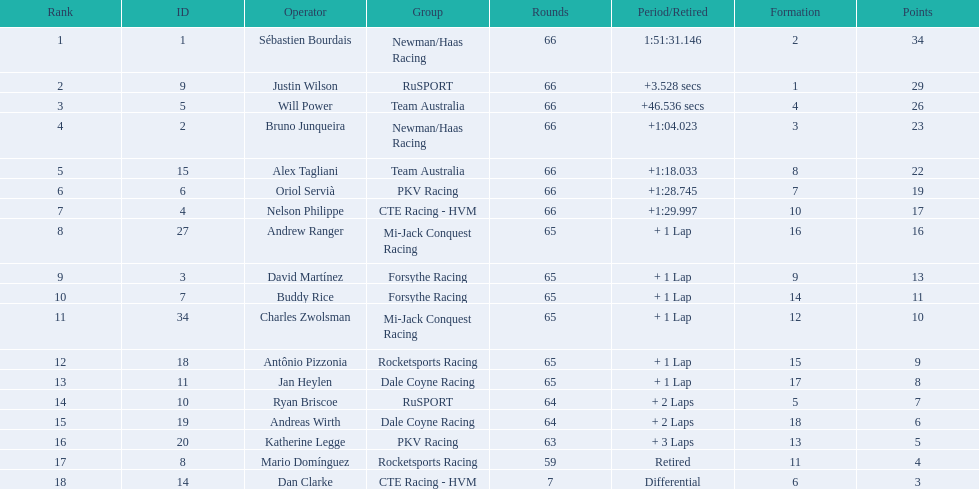Which driver has the same number as his/her position? Sébastien Bourdais. 